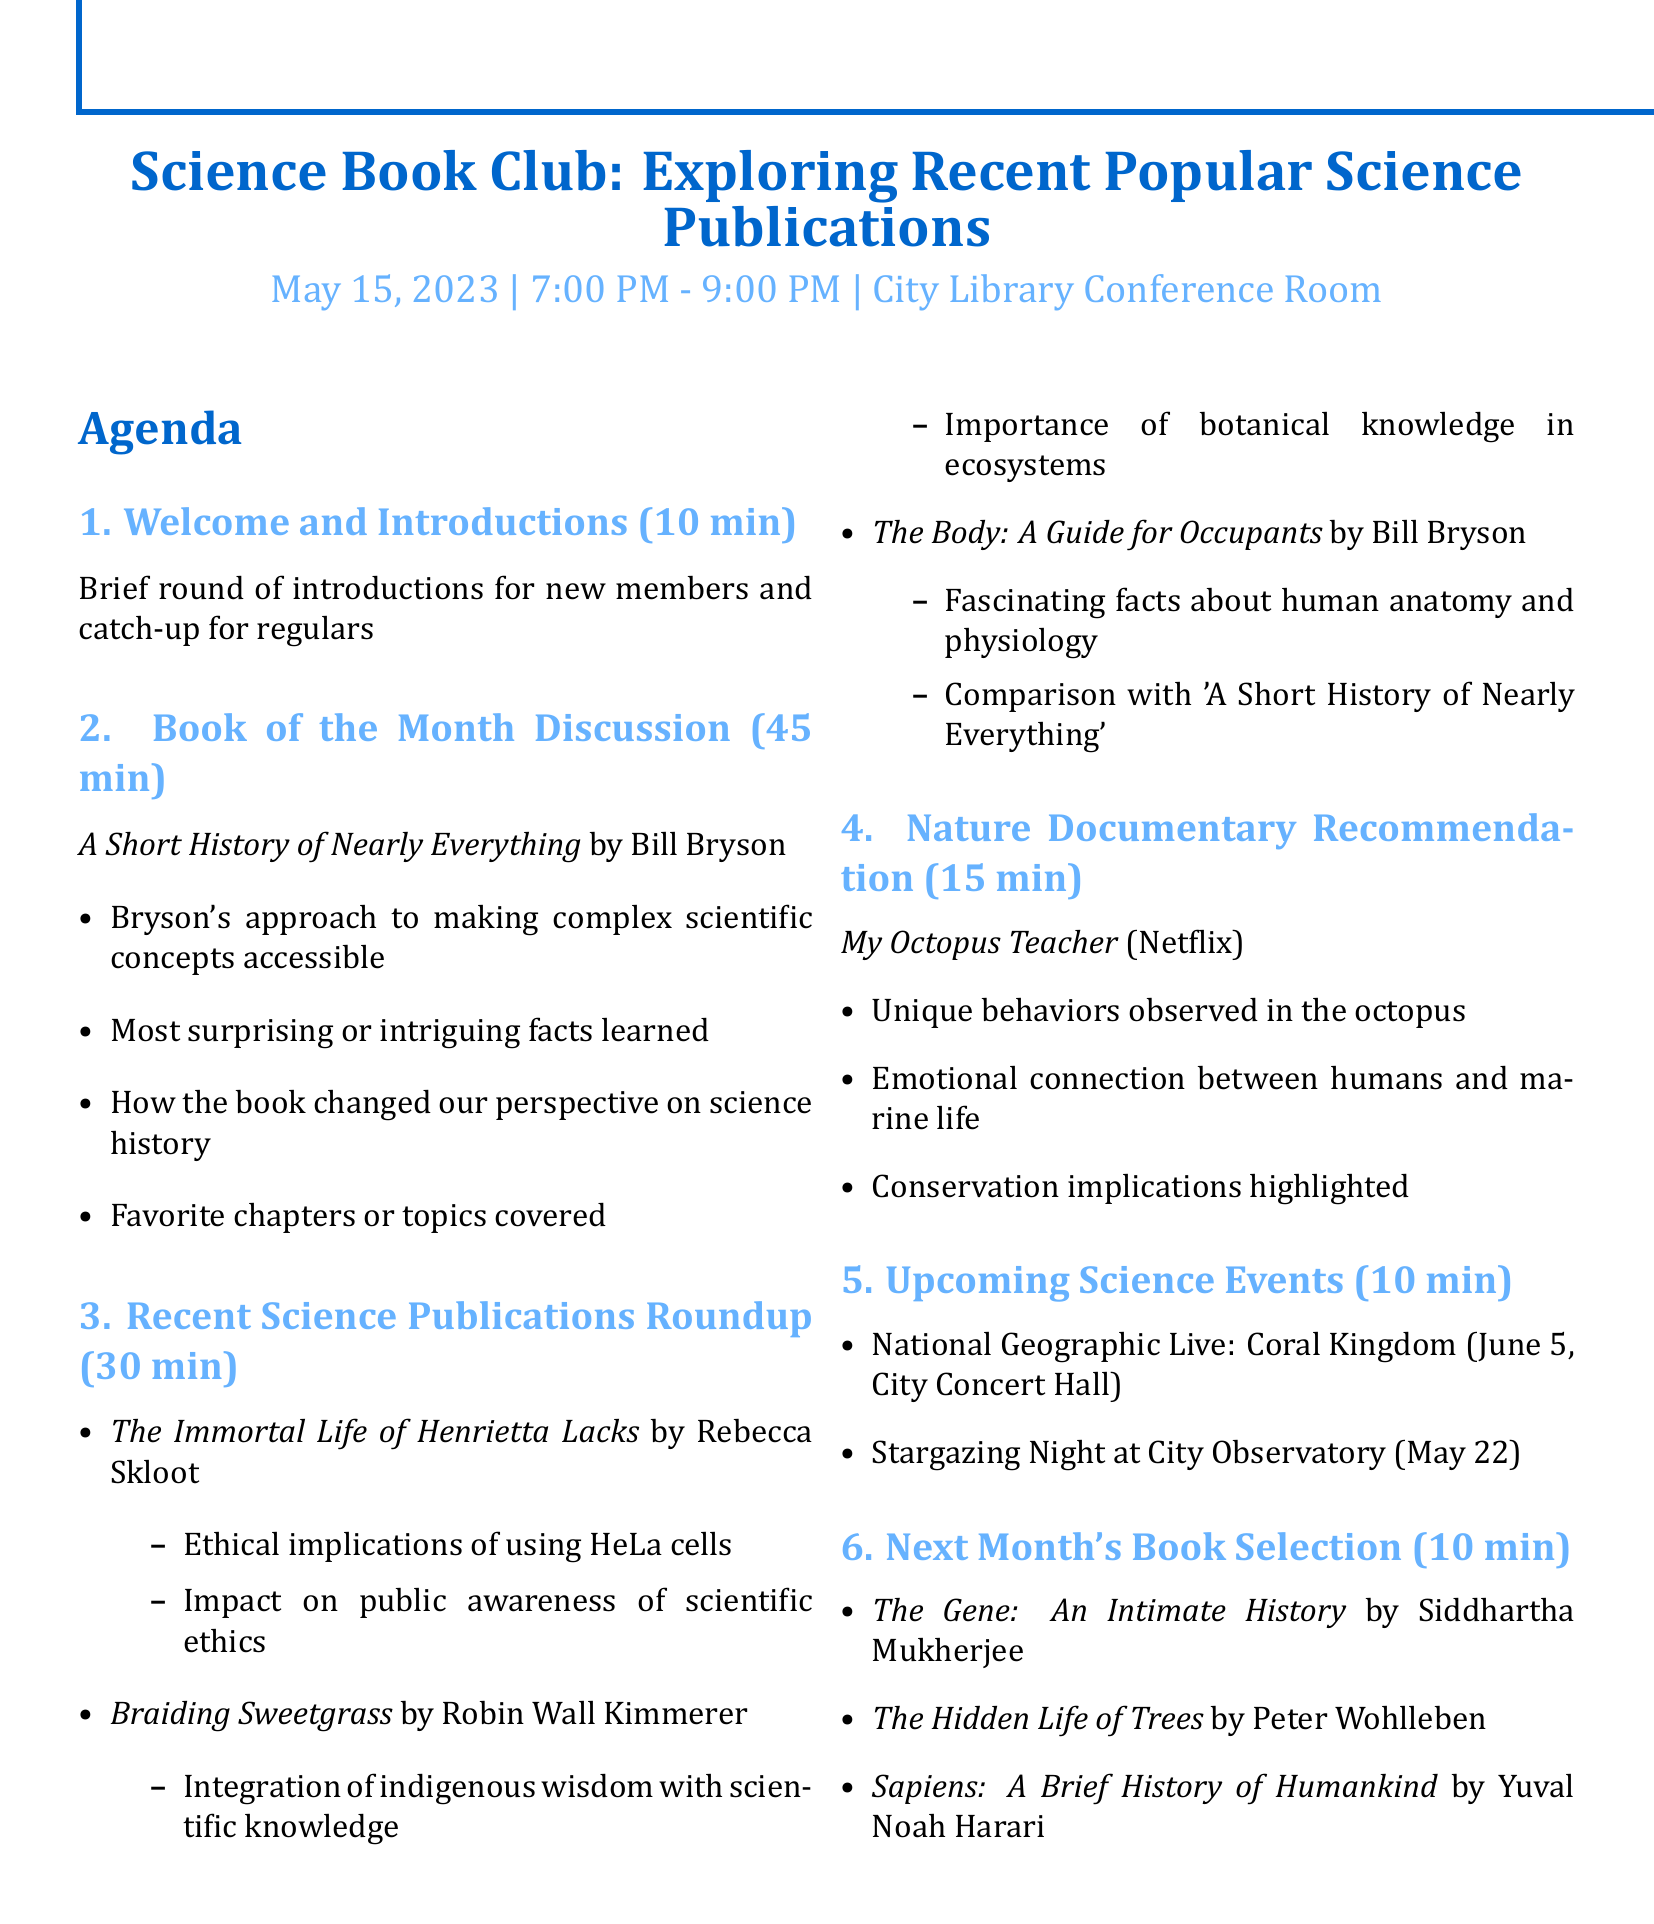What is the title of the meeting? The title of the meeting is the main subject of the document about the book club.
Answer: Science Book Club: Exploring Recent Popular Science Publications What is the name of the book being discussed as Book of the Month? The Book of the Month is explicitly listed in the agenda section.
Answer: A Short History of Nearly Everything Who is the author of the book "The Immortal Life of Henrietta Lacks"? The author is identified alongside the book title in the document.
Answer: Rebecca Skloot How long is the discussion planned for the Book of the Month? The duration allocated for the Book of the Month discussion is provided in the agenda.
Answer: 45 minutes What unique behaviors are mentioned in relation to the documentary "My Octopus Teacher"? The agenda lists example discussion points about the documentary.
Answer: Unique behaviors observed in the octopus What is the location of the "Stargazing Night at City Observatory"? The location for this upcoming science event is specified in the document.
Answer: City Observatory What are the options for next month's book selection? The document includes a list of potential books for next month.
Answer: The Gene: An Intimate History, The Hidden Life of Trees, Sapiens: A Brief History of Humankind How long is the segment for Upcoming Science Events? The duration for discussing the upcoming events is stated in the agenda.
Answer: 10 minutes What time does the meeting start? The start time for the meeting is specified in the document.
Answer: 7:00 PM 